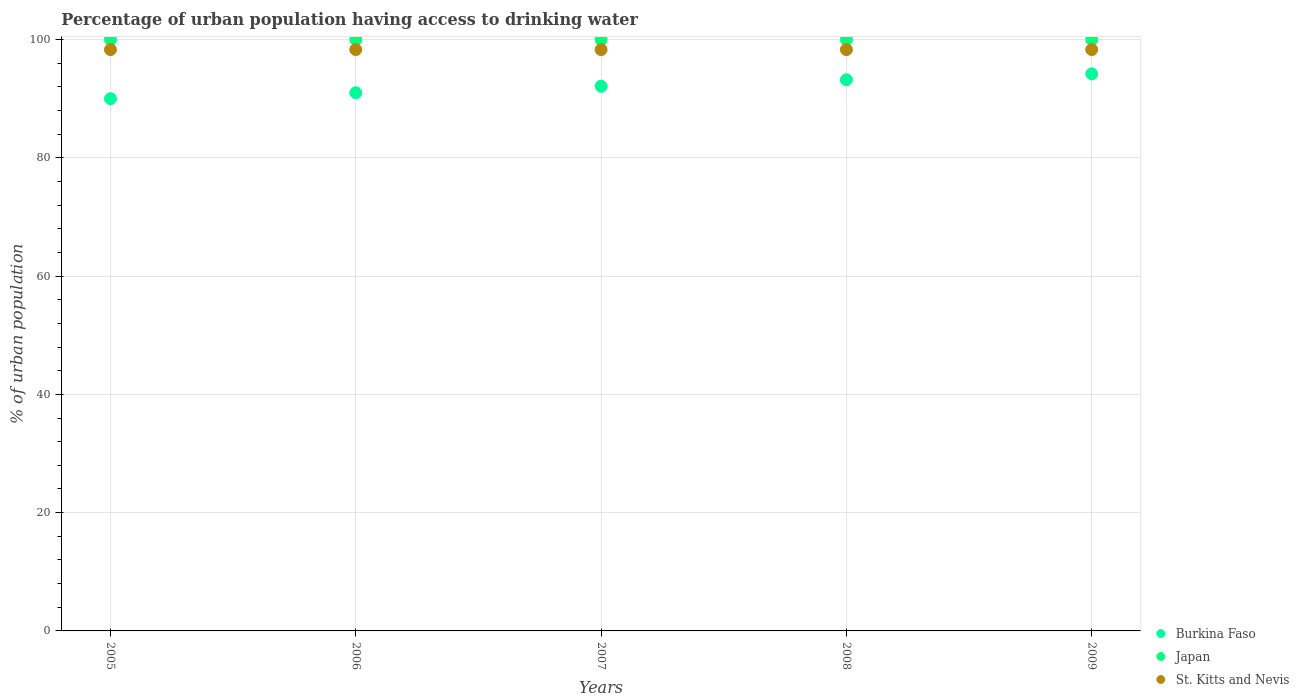How many different coloured dotlines are there?
Offer a very short reply. 3. What is the percentage of urban population having access to drinking water in Burkina Faso in 2008?
Offer a very short reply. 93.2. Across all years, what is the maximum percentage of urban population having access to drinking water in St. Kitts and Nevis?
Your answer should be very brief. 98.3. In which year was the percentage of urban population having access to drinking water in St. Kitts and Nevis minimum?
Give a very brief answer. 2005. What is the total percentage of urban population having access to drinking water in Japan in the graph?
Your answer should be compact. 500. What is the difference between the percentage of urban population having access to drinking water in Japan in 2005 and that in 2007?
Make the answer very short. 0. What is the difference between the percentage of urban population having access to drinking water in St. Kitts and Nevis in 2009 and the percentage of urban population having access to drinking water in Burkina Faso in 2007?
Ensure brevity in your answer.  6.2. What is the average percentage of urban population having access to drinking water in Burkina Faso per year?
Your answer should be very brief. 92.1. In the year 2005, what is the difference between the percentage of urban population having access to drinking water in Burkina Faso and percentage of urban population having access to drinking water in St. Kitts and Nevis?
Your answer should be compact. -8.3. In how many years, is the percentage of urban population having access to drinking water in Burkina Faso greater than 12 %?
Keep it short and to the point. 5. Is the difference between the percentage of urban population having access to drinking water in Burkina Faso in 2005 and 2006 greater than the difference between the percentage of urban population having access to drinking water in St. Kitts and Nevis in 2005 and 2006?
Offer a very short reply. No. What is the difference between the highest and the second highest percentage of urban population having access to drinking water in St. Kitts and Nevis?
Keep it short and to the point. 0. In how many years, is the percentage of urban population having access to drinking water in Burkina Faso greater than the average percentage of urban population having access to drinking water in Burkina Faso taken over all years?
Make the answer very short. 2. Is the sum of the percentage of urban population having access to drinking water in Japan in 2006 and 2009 greater than the maximum percentage of urban population having access to drinking water in Burkina Faso across all years?
Your answer should be compact. Yes. Is it the case that in every year, the sum of the percentage of urban population having access to drinking water in Japan and percentage of urban population having access to drinking water in Burkina Faso  is greater than the percentage of urban population having access to drinking water in St. Kitts and Nevis?
Offer a very short reply. Yes. How many years are there in the graph?
Offer a terse response. 5. What is the difference between two consecutive major ticks on the Y-axis?
Give a very brief answer. 20. Does the graph contain any zero values?
Give a very brief answer. No. How many legend labels are there?
Your response must be concise. 3. What is the title of the graph?
Make the answer very short. Percentage of urban population having access to drinking water. Does "Venezuela" appear as one of the legend labels in the graph?
Provide a succinct answer. No. What is the label or title of the X-axis?
Your answer should be compact. Years. What is the label or title of the Y-axis?
Your response must be concise. % of urban population. What is the % of urban population in Burkina Faso in 2005?
Provide a short and direct response. 90. What is the % of urban population of St. Kitts and Nevis in 2005?
Ensure brevity in your answer.  98.3. What is the % of urban population in Burkina Faso in 2006?
Your answer should be compact. 91. What is the % of urban population in Japan in 2006?
Give a very brief answer. 100. What is the % of urban population in St. Kitts and Nevis in 2006?
Give a very brief answer. 98.3. What is the % of urban population of Burkina Faso in 2007?
Provide a succinct answer. 92.1. What is the % of urban population of St. Kitts and Nevis in 2007?
Your answer should be very brief. 98.3. What is the % of urban population of Burkina Faso in 2008?
Provide a succinct answer. 93.2. What is the % of urban population in Japan in 2008?
Provide a succinct answer. 100. What is the % of urban population in St. Kitts and Nevis in 2008?
Offer a terse response. 98.3. What is the % of urban population in Burkina Faso in 2009?
Your answer should be compact. 94.2. What is the % of urban population of Japan in 2009?
Your answer should be very brief. 100. What is the % of urban population of St. Kitts and Nevis in 2009?
Make the answer very short. 98.3. Across all years, what is the maximum % of urban population in Burkina Faso?
Make the answer very short. 94.2. Across all years, what is the maximum % of urban population in Japan?
Ensure brevity in your answer.  100. Across all years, what is the maximum % of urban population in St. Kitts and Nevis?
Provide a succinct answer. 98.3. Across all years, what is the minimum % of urban population in Burkina Faso?
Make the answer very short. 90. Across all years, what is the minimum % of urban population of Japan?
Provide a short and direct response. 100. Across all years, what is the minimum % of urban population in St. Kitts and Nevis?
Make the answer very short. 98.3. What is the total % of urban population of Burkina Faso in the graph?
Your answer should be very brief. 460.5. What is the total % of urban population in Japan in the graph?
Make the answer very short. 500. What is the total % of urban population in St. Kitts and Nevis in the graph?
Offer a very short reply. 491.5. What is the difference between the % of urban population of Burkina Faso in 2005 and that in 2006?
Give a very brief answer. -1. What is the difference between the % of urban population in Japan in 2005 and that in 2006?
Keep it short and to the point. 0. What is the difference between the % of urban population in Japan in 2005 and that in 2007?
Provide a short and direct response. 0. What is the difference between the % of urban population of St. Kitts and Nevis in 2005 and that in 2007?
Ensure brevity in your answer.  0. What is the difference between the % of urban population in Burkina Faso in 2005 and that in 2008?
Make the answer very short. -3.2. What is the difference between the % of urban population of Burkina Faso in 2005 and that in 2009?
Provide a succinct answer. -4.2. What is the difference between the % of urban population in Japan in 2005 and that in 2009?
Your answer should be compact. 0. What is the difference between the % of urban population of Burkina Faso in 2006 and that in 2008?
Provide a succinct answer. -2.2. What is the difference between the % of urban population of Burkina Faso in 2006 and that in 2009?
Provide a short and direct response. -3.2. What is the difference between the % of urban population of Japan in 2006 and that in 2009?
Make the answer very short. 0. What is the difference between the % of urban population in Japan in 2007 and that in 2008?
Your response must be concise. 0. What is the difference between the % of urban population of Burkina Faso in 2007 and that in 2009?
Your answer should be compact. -2.1. What is the difference between the % of urban population of Japan in 2007 and that in 2009?
Your answer should be compact. 0. What is the difference between the % of urban population in St. Kitts and Nevis in 2007 and that in 2009?
Ensure brevity in your answer.  0. What is the difference between the % of urban population in Burkina Faso in 2008 and that in 2009?
Keep it short and to the point. -1. What is the difference between the % of urban population in Burkina Faso in 2005 and the % of urban population in Japan in 2006?
Keep it short and to the point. -10. What is the difference between the % of urban population of Japan in 2005 and the % of urban population of St. Kitts and Nevis in 2006?
Ensure brevity in your answer.  1.7. What is the difference between the % of urban population of Burkina Faso in 2005 and the % of urban population of Japan in 2007?
Your answer should be very brief. -10. What is the difference between the % of urban population in Burkina Faso in 2005 and the % of urban population in Japan in 2008?
Your answer should be compact. -10. What is the difference between the % of urban population in Burkina Faso in 2005 and the % of urban population in St. Kitts and Nevis in 2009?
Your answer should be compact. -8.3. What is the difference between the % of urban population in Japan in 2005 and the % of urban population in St. Kitts and Nevis in 2009?
Provide a succinct answer. 1.7. What is the difference between the % of urban population in Burkina Faso in 2006 and the % of urban population in St. Kitts and Nevis in 2007?
Provide a succinct answer. -7.3. What is the difference between the % of urban population in Japan in 2006 and the % of urban population in St. Kitts and Nevis in 2007?
Offer a terse response. 1.7. What is the difference between the % of urban population in Burkina Faso in 2006 and the % of urban population in Japan in 2008?
Your answer should be very brief. -9. What is the difference between the % of urban population of Burkina Faso in 2006 and the % of urban population of Japan in 2009?
Ensure brevity in your answer.  -9. What is the difference between the % of urban population of Burkina Faso in 2007 and the % of urban population of St. Kitts and Nevis in 2008?
Provide a succinct answer. -6.2. What is the difference between the % of urban population of Burkina Faso in 2007 and the % of urban population of Japan in 2009?
Provide a succinct answer. -7.9. What is the difference between the % of urban population of Burkina Faso in 2007 and the % of urban population of St. Kitts and Nevis in 2009?
Ensure brevity in your answer.  -6.2. What is the difference between the % of urban population in Burkina Faso in 2008 and the % of urban population in St. Kitts and Nevis in 2009?
Ensure brevity in your answer.  -5.1. What is the average % of urban population of Burkina Faso per year?
Make the answer very short. 92.1. What is the average % of urban population in St. Kitts and Nevis per year?
Keep it short and to the point. 98.3. In the year 2005, what is the difference between the % of urban population of Burkina Faso and % of urban population of Japan?
Your response must be concise. -10. In the year 2005, what is the difference between the % of urban population in Japan and % of urban population in St. Kitts and Nevis?
Provide a short and direct response. 1.7. In the year 2007, what is the difference between the % of urban population in Burkina Faso and % of urban population in St. Kitts and Nevis?
Ensure brevity in your answer.  -6.2. In the year 2009, what is the difference between the % of urban population in Japan and % of urban population in St. Kitts and Nevis?
Provide a short and direct response. 1.7. What is the ratio of the % of urban population in Burkina Faso in 2005 to that in 2007?
Offer a very short reply. 0.98. What is the ratio of the % of urban population in Japan in 2005 to that in 2007?
Ensure brevity in your answer.  1. What is the ratio of the % of urban population in Burkina Faso in 2005 to that in 2008?
Keep it short and to the point. 0.97. What is the ratio of the % of urban population of St. Kitts and Nevis in 2005 to that in 2008?
Ensure brevity in your answer.  1. What is the ratio of the % of urban population in Burkina Faso in 2005 to that in 2009?
Your response must be concise. 0.96. What is the ratio of the % of urban population of Japan in 2005 to that in 2009?
Give a very brief answer. 1. What is the ratio of the % of urban population in Burkina Faso in 2006 to that in 2007?
Ensure brevity in your answer.  0.99. What is the ratio of the % of urban population of Japan in 2006 to that in 2007?
Offer a terse response. 1. What is the ratio of the % of urban population of Burkina Faso in 2006 to that in 2008?
Offer a terse response. 0.98. What is the ratio of the % of urban population in St. Kitts and Nevis in 2006 to that in 2008?
Provide a short and direct response. 1. What is the ratio of the % of urban population in Burkina Faso in 2006 to that in 2009?
Give a very brief answer. 0.97. What is the ratio of the % of urban population in Japan in 2006 to that in 2009?
Your answer should be very brief. 1. What is the ratio of the % of urban population of Japan in 2007 to that in 2008?
Ensure brevity in your answer.  1. What is the ratio of the % of urban population of St. Kitts and Nevis in 2007 to that in 2008?
Your response must be concise. 1. What is the ratio of the % of urban population of Burkina Faso in 2007 to that in 2009?
Offer a very short reply. 0.98. What is the ratio of the % of urban population in Japan in 2007 to that in 2009?
Provide a succinct answer. 1. What is the ratio of the % of urban population of Burkina Faso in 2008 to that in 2009?
Ensure brevity in your answer.  0.99. What is the ratio of the % of urban population in St. Kitts and Nevis in 2008 to that in 2009?
Provide a short and direct response. 1. What is the difference between the highest and the second highest % of urban population of Burkina Faso?
Provide a short and direct response. 1. What is the difference between the highest and the second highest % of urban population of Japan?
Keep it short and to the point. 0. What is the difference between the highest and the lowest % of urban population in Burkina Faso?
Make the answer very short. 4.2. What is the difference between the highest and the lowest % of urban population of St. Kitts and Nevis?
Your response must be concise. 0. 